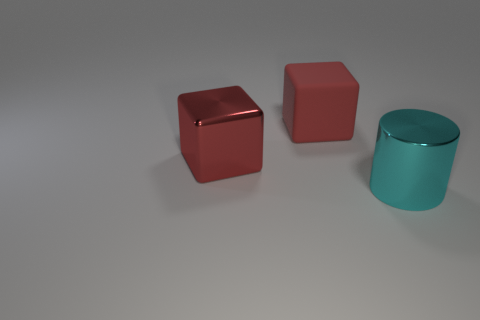What number of cylinders are either small cyan rubber objects or rubber things?
Offer a terse response. 0. There is a red thing that is on the left side of the large matte block; does it have the same size as the cyan metallic object that is right of the red matte block?
Ensure brevity in your answer.  Yes. There is a block that is in front of the large object behind the red metallic thing; what is its material?
Give a very brief answer. Metal. Is the number of red shiny cubes to the left of the red shiny cube less than the number of shiny blocks?
Your answer should be very brief. Yes. The large thing that is the same material as the big cyan cylinder is what shape?
Your answer should be very brief. Cube. What number of other objects are there of the same shape as the big cyan thing?
Keep it short and to the point. 0. What number of red things are either large metal cylinders or metal blocks?
Offer a terse response. 1. Does the large rubber thing have the same shape as the cyan object?
Keep it short and to the point. No. Is there a shiny cylinder that is behind the metal object that is behind the big cylinder?
Offer a terse response. No. Are there the same number of large red blocks on the right side of the large red matte thing and small purple matte cylinders?
Ensure brevity in your answer.  Yes. 